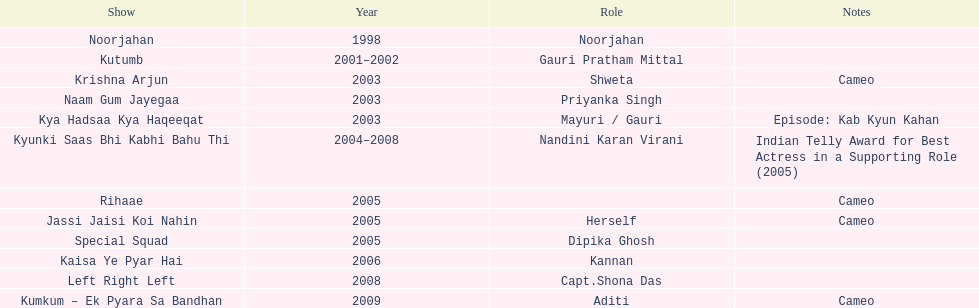Which was the only television show gauri starred in, in which she played herself? Jassi Jaisi Koi Nahin. 